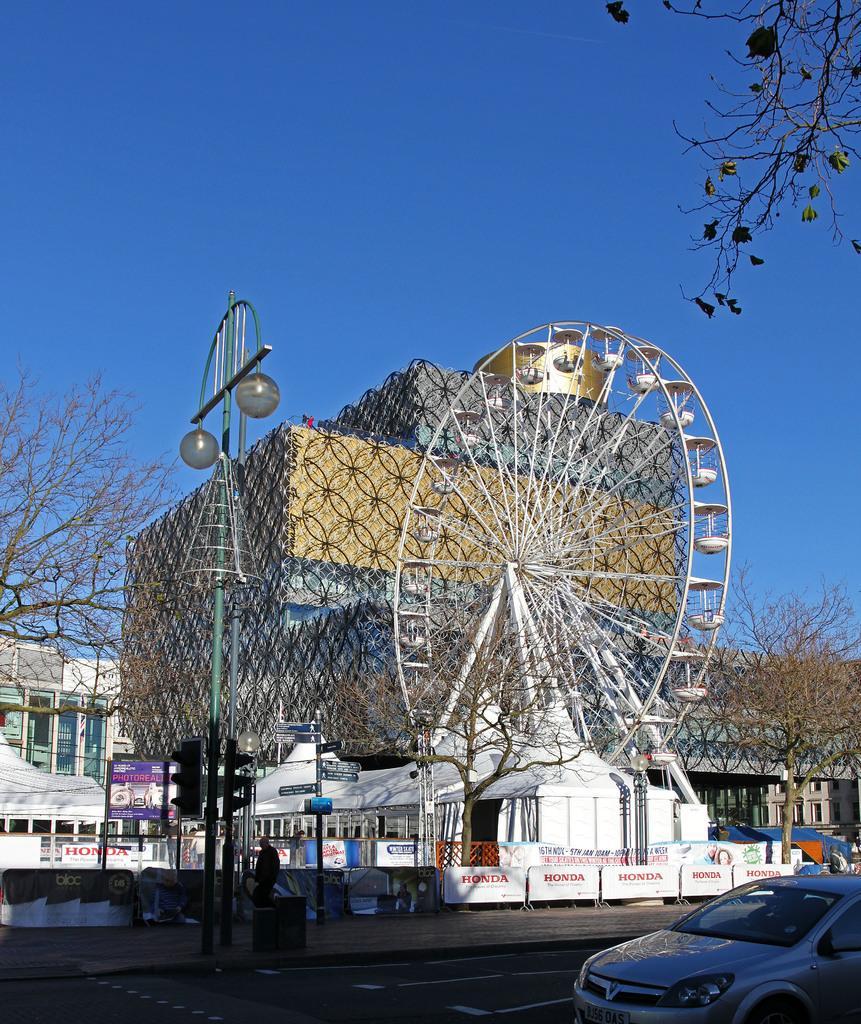How would you summarize this image in a sentence or two? In this picture we can see a car on the road and behind the car there is a pole with traffic signals and lights, control barriers and trees. Behind the control barriers there is a giant wheel, trees, buildings and sky. 